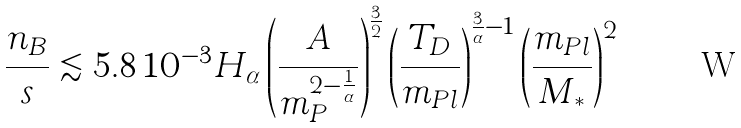<formula> <loc_0><loc_0><loc_500><loc_500>\frac { n _ { B } } { s } \lesssim 5 . 8 \, 1 0 ^ { - 3 } H _ { \alpha } \left ( \frac { A } { m _ { P } ^ { 2 - \frac { 1 } { \alpha } } } \right ) ^ { \frac { 3 } { 2 } } \left ( \frac { T _ { D } } { m _ { P l } } \right ) ^ { \frac { 3 } { \alpha } - 1 } \left ( \frac { m _ { P l } } { M _ { * } } \right ) ^ { 2 }</formula> 